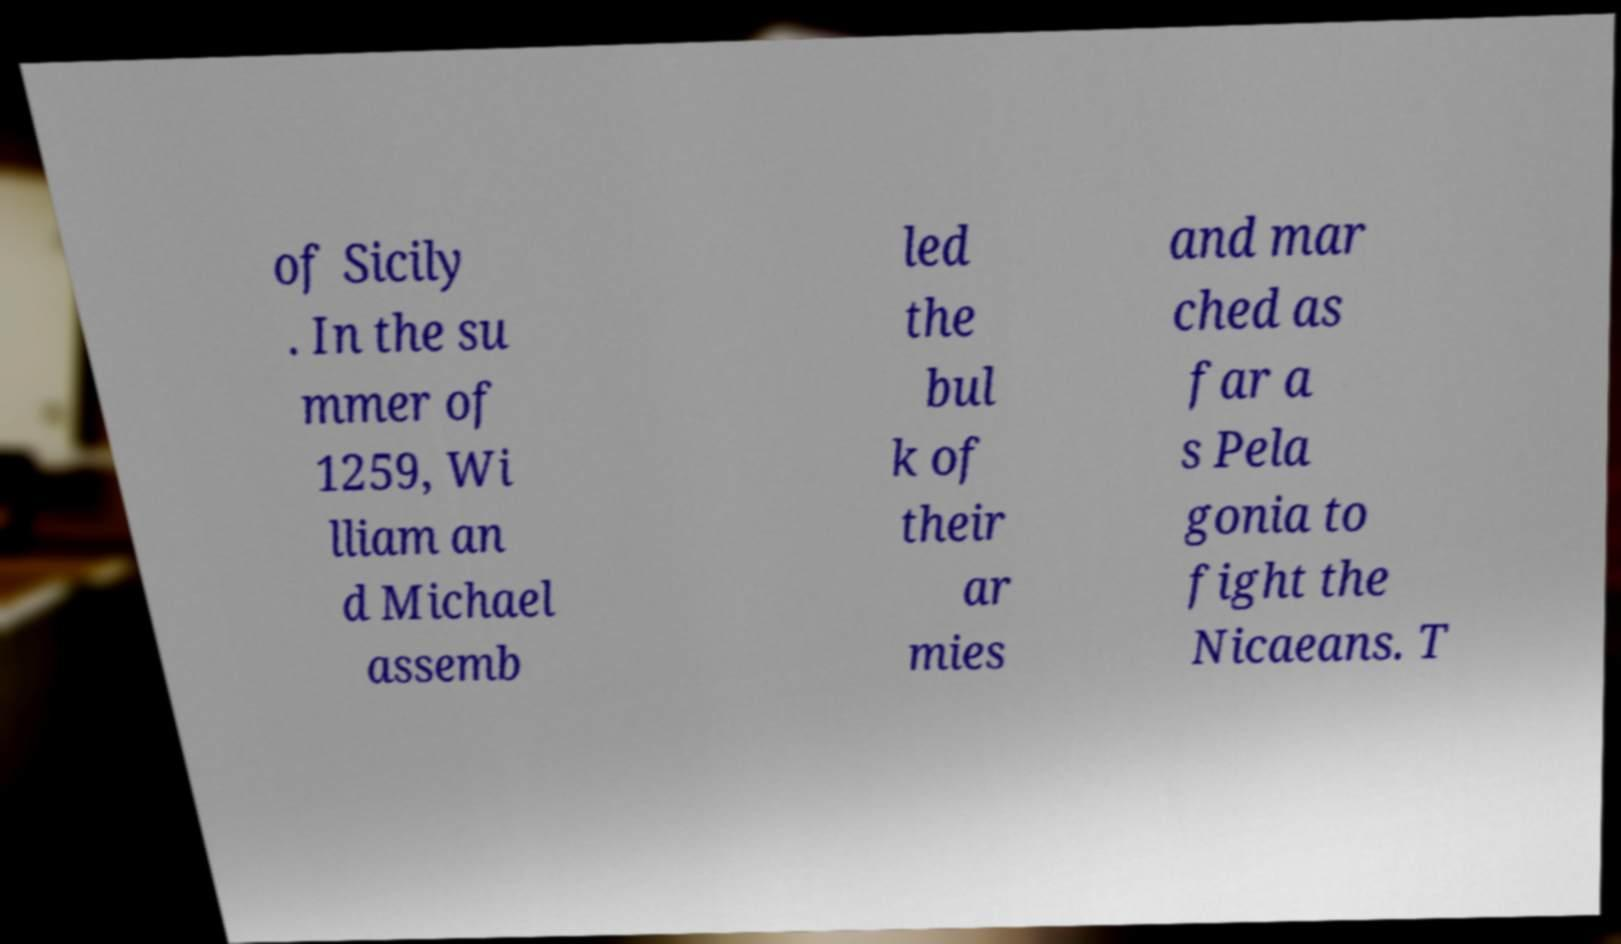Please read and relay the text visible in this image. What does it say? of Sicily . In the su mmer of 1259, Wi lliam an d Michael assemb led the bul k of their ar mies and mar ched as far a s Pela gonia to fight the Nicaeans. T 